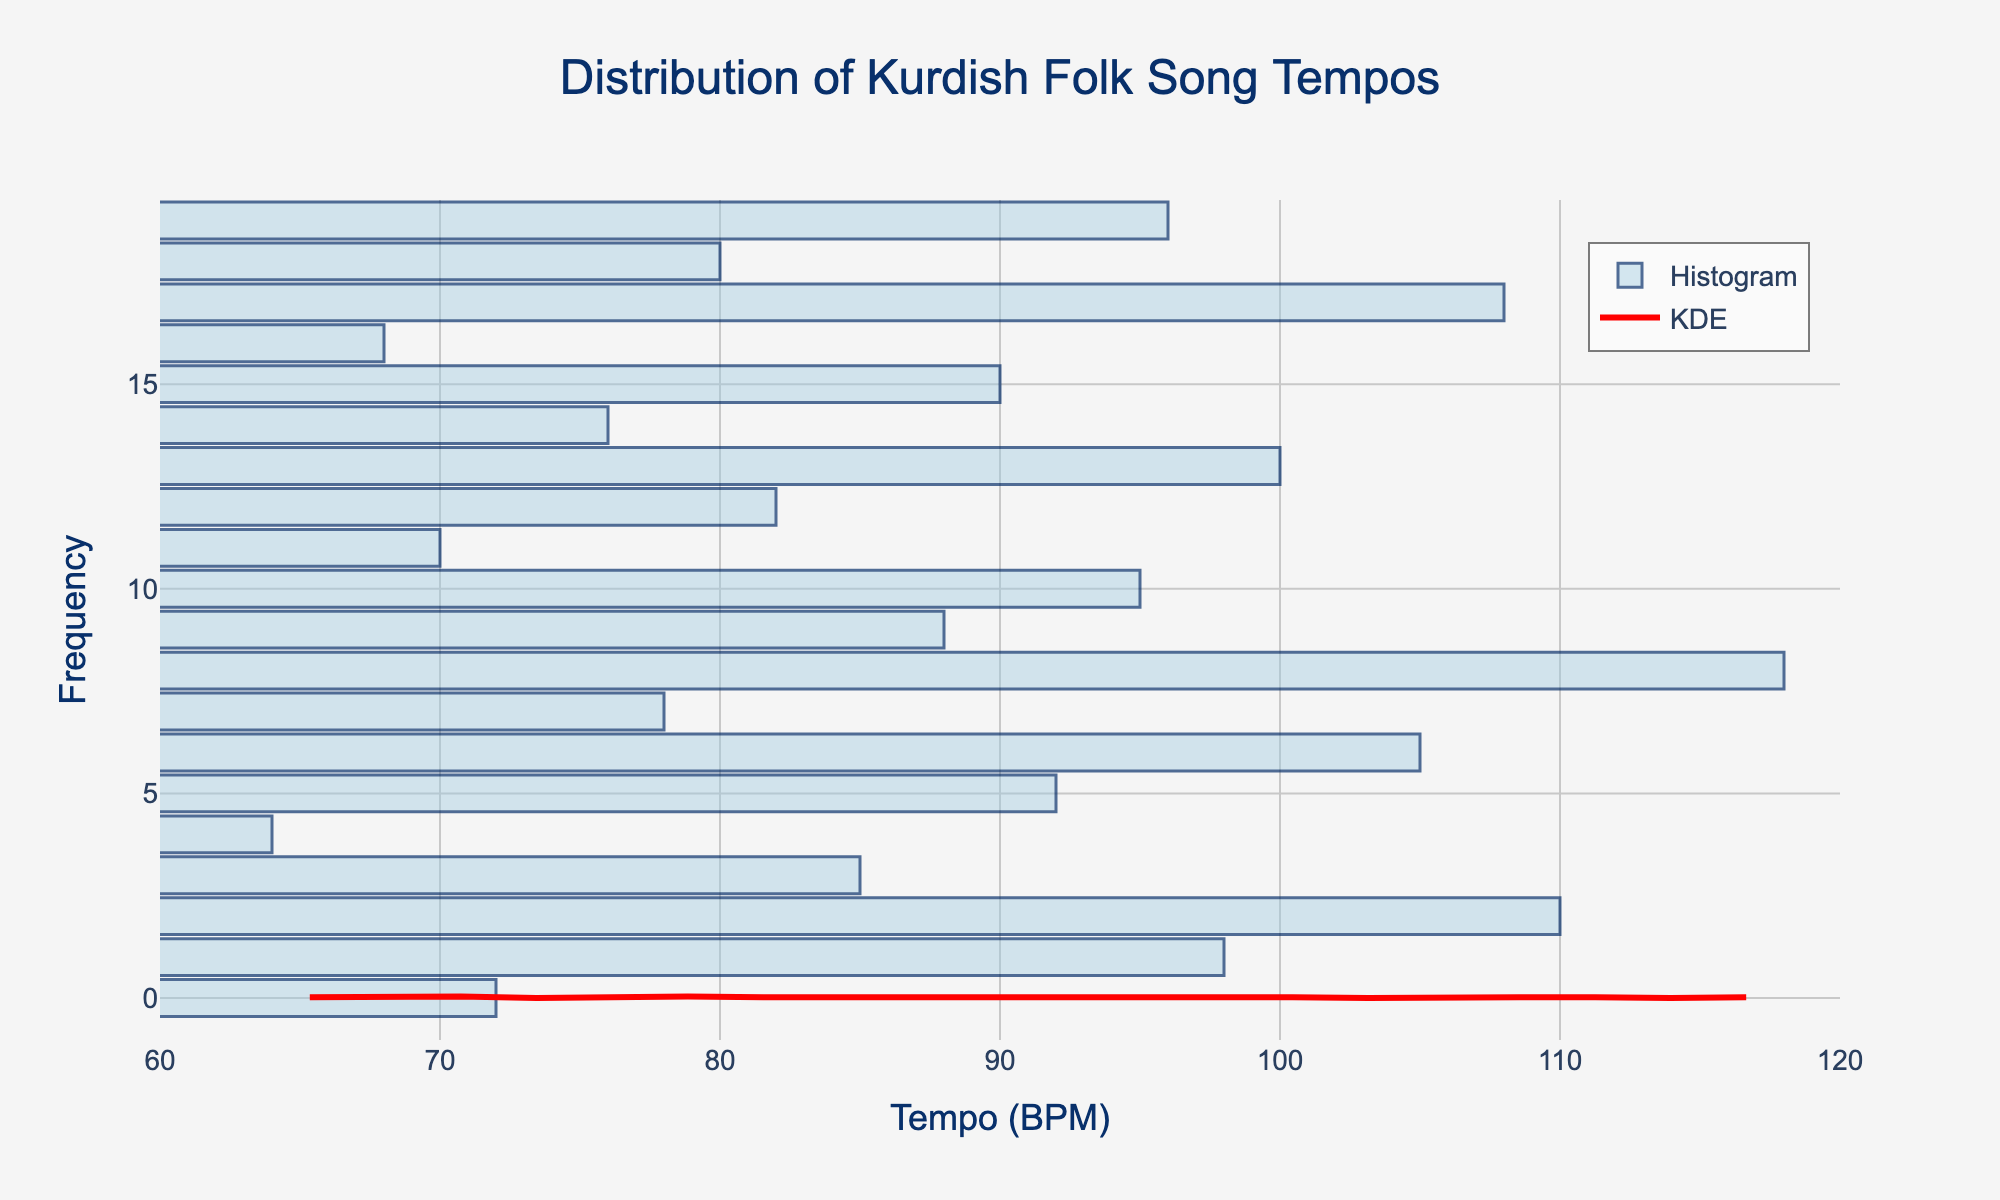What is the title of the figure? The title of the figure is typically located at the top center of the plot. It summarizes the main theme or insight of the figure. By reading the title directly, we understand that this figure represents the distribution of Kurdish folk song tempos.
Answer: Distribution of Kurdish Folk Song Tempos What are the units for the x-axis? The x-axis title provides the information regarding the units. From there, we can see that the unit used for this data is beats per minute (BPM).
Answer: BPM How many songs have a tempo of 72 BPM? On the histogram, look at the bars to identify how many songs fall into the 72 BPM category. The height of the bar at 72 BPM will directly tell us the number of songs.
Answer: 1 At what approximate BPM value does the density curve (KDE) peak? Look for the highest point on the density curve (KDE). The BPM value at this highest point is where the density curve peaks.
Answer: Around 85 BPM What is the range of the tempos displayed on the x-axis? Check the x-axis values to see the lowest and highest BPMs marked there. This will give the overall range of the song tempos represented in the figure.
Answer: 60 to 120 BPM Which tempo category, 90 BPM or 100 BPM, has more song frequencies? Compare the heights of the bars at 90 BPM and 100 BPM on the histogram. The taller bar indicates the category with more frequencies.
Answer: 100 BPM How do the number and distribution of song tempos between 70-80 BPM compare to those between 100-110 BPM? Count the bars between the ranges 70-80 BPM and 100-110 BPM, and observe their heights. Describe whether one range has more or fewer songs and how spread out the bars are.
Answer: 70-80 BPM has fewer and more spread-out songs compared to the denser distribution in 100-110 BPM What is the median tempo of the Kurdish folk songs in this dataset? The median can be found by listing all tempos in ascending order and picking the middle value. With 19 songs, the median will be the tempo of the 10th song in the ordered list.
Answer: 85 BPM Is there a tempo that appears to be an outlier in this dataset? Look at the histogram and KDE curve to identify if there's any tempo that stands far from the central range (60-120 BPM) with fewer songs around it.
Answer: No significant outlier Do more Kurdish folk songs in the dataset tend to have slower tempos (below 80 BPM) or faster tempos (above 80 BPM)? Count the number of songs in the histogram bars below 80 BPM and compare them with the number of songs in bars above 80 BPM.
Answer: More songs have faster tempos (above 80 BPM) 